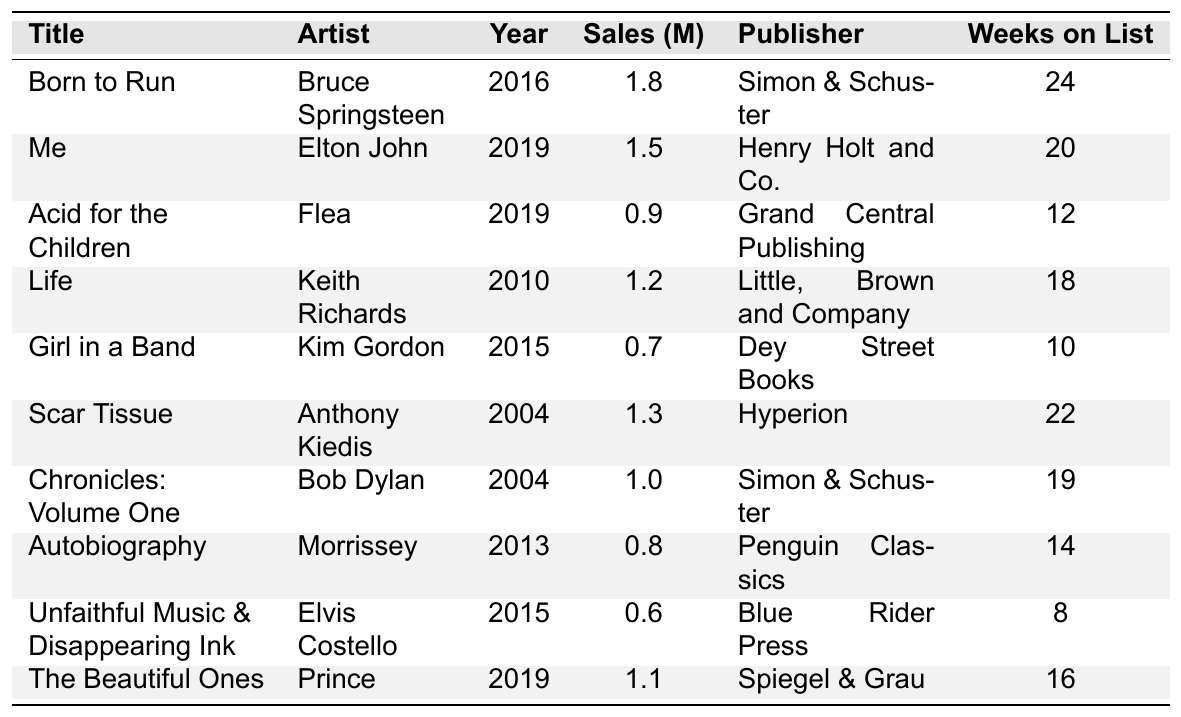What is the title of the biography with the highest sales? The biography with the highest sales is "Born to Run", which sold 1.8 million copies.
Answer: Born to Run Which artist has a biography published by Simon & Schuster? "Born to Run" by Bruce Springsteen and "Chronicles: Volume One" by Bob Dylan are both published by Simon & Schuster.
Answer: Bruce Springsteen, Bob Dylan How many weeks did "Acid for the Children" remain on the bestseller list? The biography "Acid for the Children" by Flea was on the bestseller list for 12 weeks.
Answer: 12 weeks What is the total sales of biographical works from the year 2019? The biographies from 2019 are "Me", "Acid for the Children", and "The Beautiful Ones", with sales of 1.5 million, 0.9 million, and 1.1 million respectively, summing up to 3.5 million.
Answer: 3.5 million Which biography sold more than 1 million copies but had fewer than 20 weeks on the bestseller list? The biography "The Beautiful Ones" by Prince sold 1.1 million copies and was on the list for 16 weeks.
Answer: The Beautiful Ones Is "Life" by Keith Richards the only biography released in 2010? Yes, "Life" by Keith Richards is the only biography listed from the year 2010.
Answer: Yes Calculate the average sales (in millions) of the biographies published by Dey Street Books and Penguin Classics. "Girl in a Band" by Kim Gordon (0.7 million) and "Autobiography" by Morrissey (0.8 million) are published by Dey Street Books and Penguin Classics respectively; the average sales is (0.7 + 0.8) / 2 = 0.75 million.
Answer: 0.75 million Which artist has the most weeks on the bestseller list? Bruce Springsteen's "Born to Run" was on the bestseller list for 24 weeks, the highest among the listed biographies.
Answer: Bruce Springsteen Is there a biography that sold less than 1 million copies and stayed on the bestseller list for more than 10 weeks? Yes, "Acid for the Children" by Flea sold 0.9 million copies and was on the list for 12 weeks, matching the criteria.
Answer: Yes What is the difference in sales between "Me" by Elton John and "Scar Tissue" by Anthony Kiedis? "Me" sold 1.5 million copies and "Scar Tissue" sold 1.3 million. The difference is 1.5 - 1.3 = 0.2 million.
Answer: 0.2 million 